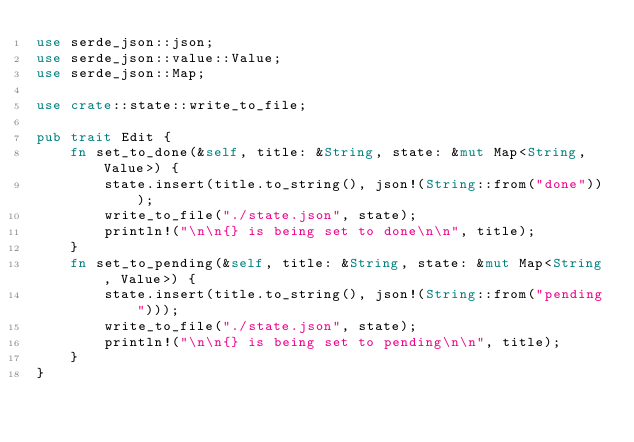Convert code to text. <code><loc_0><loc_0><loc_500><loc_500><_Rust_>use serde_json::json;
use serde_json::value::Value;
use serde_json::Map;

use crate::state::write_to_file;

pub trait Edit {
    fn set_to_done(&self, title: &String, state: &mut Map<String, Value>) {
        state.insert(title.to_string(), json!(String::from("done")));
        write_to_file("./state.json", state);
        println!("\n\n{} is being set to done\n\n", title);
    }
    fn set_to_pending(&self, title: &String, state: &mut Map<String, Value>) {
        state.insert(title.to_string(), json!(String::from("pending")));
        write_to_file("./state.json", state);
        println!("\n\n{} is being set to pending\n\n", title);
    }
}
</code> 